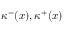Convert formula to latex. <formula><loc_0><loc_0><loc_500><loc_500>\kappa ^ { - } ( x ) , \kappa ^ { + } ( x )</formula> 